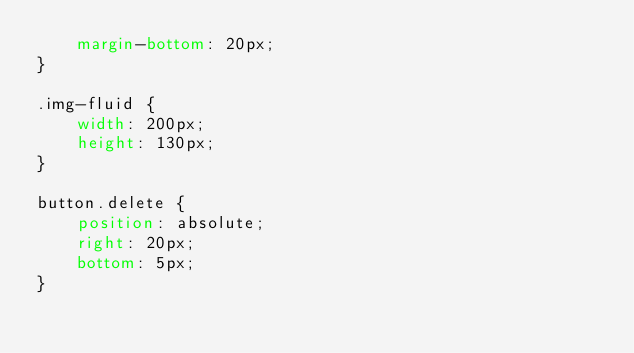Convert code to text. <code><loc_0><loc_0><loc_500><loc_500><_CSS_>    margin-bottom: 20px;
}

.img-fluid {
    width: 200px;
    height: 130px;
}

button.delete {
    position: absolute;
    right: 20px;
    bottom: 5px;
}</code> 